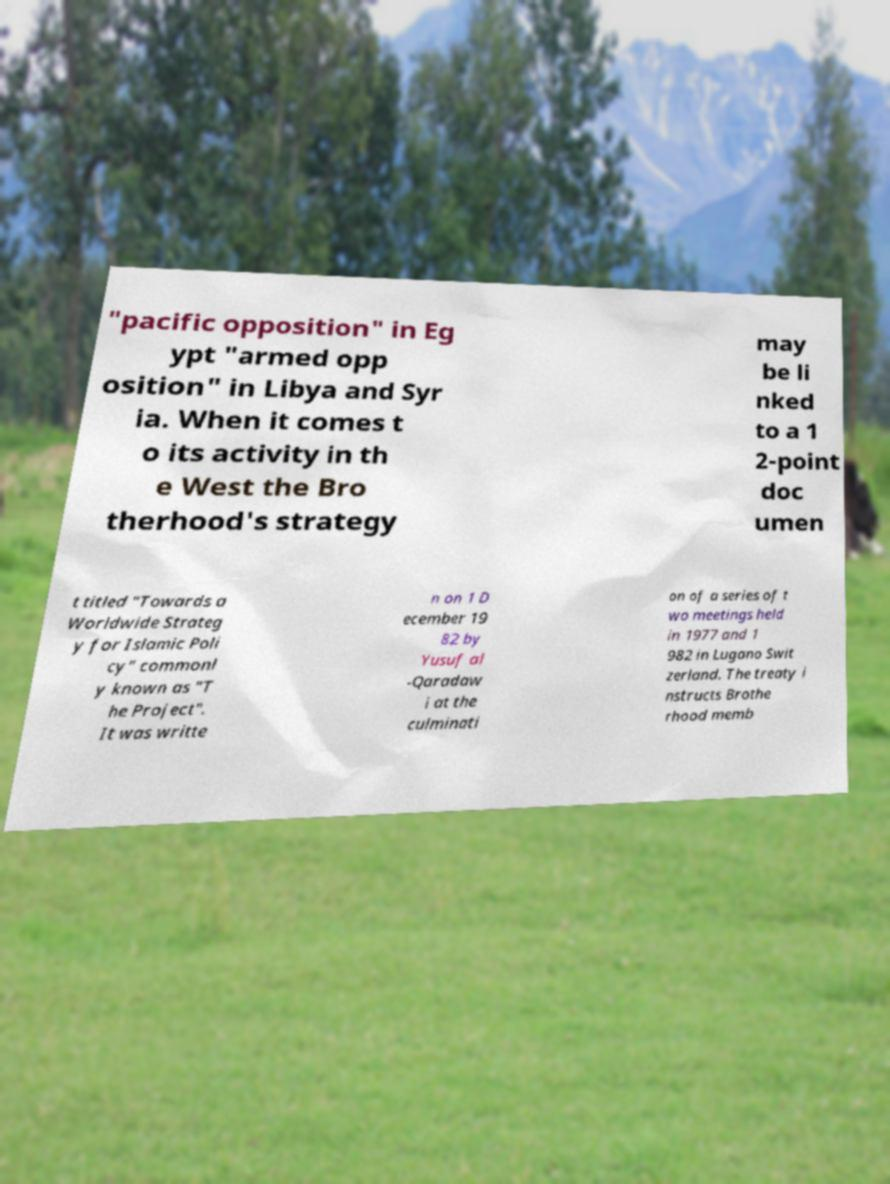For documentation purposes, I need the text within this image transcribed. Could you provide that? "pacific opposition" in Eg ypt "armed opp osition" in Libya and Syr ia. When it comes t o its activity in th e West the Bro therhood's strategy may be li nked to a 1 2-point doc umen t titled "Towards a Worldwide Strateg y for Islamic Poli cy" commonl y known as "T he Project". It was writte n on 1 D ecember 19 82 by Yusuf al -Qaradaw i at the culminati on of a series of t wo meetings held in 1977 and 1 982 in Lugano Swit zerland. The treaty i nstructs Brothe rhood memb 